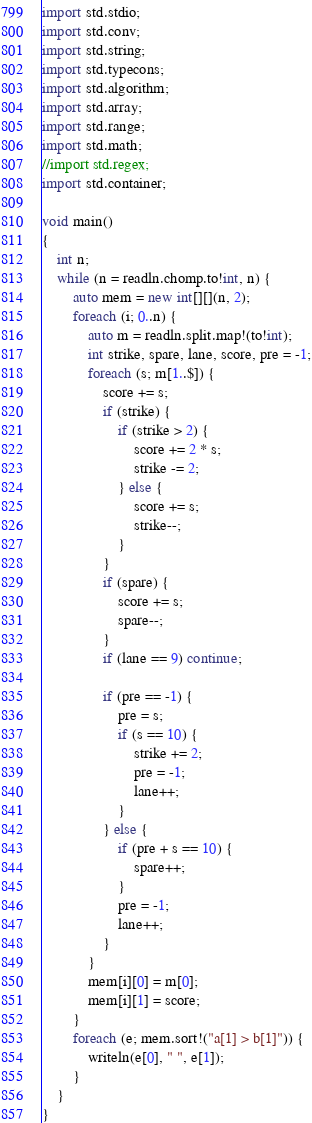Convert code to text. <code><loc_0><loc_0><loc_500><loc_500><_D_>import std.stdio;
import std.conv;
import std.string;
import std.typecons;
import std.algorithm;
import std.array;
import std.range;
import std.math;
//import std.regex;
import std.container;

void main()
{
	int n;
	while (n = readln.chomp.to!int, n) {
		auto mem = new int[][](n, 2);
		foreach (i; 0..n) {
			auto m = readln.split.map!(to!int);
			int strike, spare, lane, score, pre = -1;
			foreach (s; m[1..$]) {
				score += s;
				if (strike) {
					if (strike > 2) {
						score += 2 * s;
						strike -= 2;
					} else {
						score += s;
						strike--;
					}
				}
				if (spare) {
					score += s;
					spare--;
				}
				if (lane == 9) continue;

				if (pre == -1) {
					pre = s;
					if (s == 10) {
						strike += 2;
						pre = -1;
						lane++;
					}
				} else {
					if (pre + s == 10) {
						spare++;
					}
					pre = -1;
					lane++;
				}
			}
			mem[i][0] = m[0];
			mem[i][1] = score;
		}
		foreach (e; mem.sort!("a[1] > b[1]")) {
			writeln(e[0], " ", e[1]);
		}
	}
}</code> 